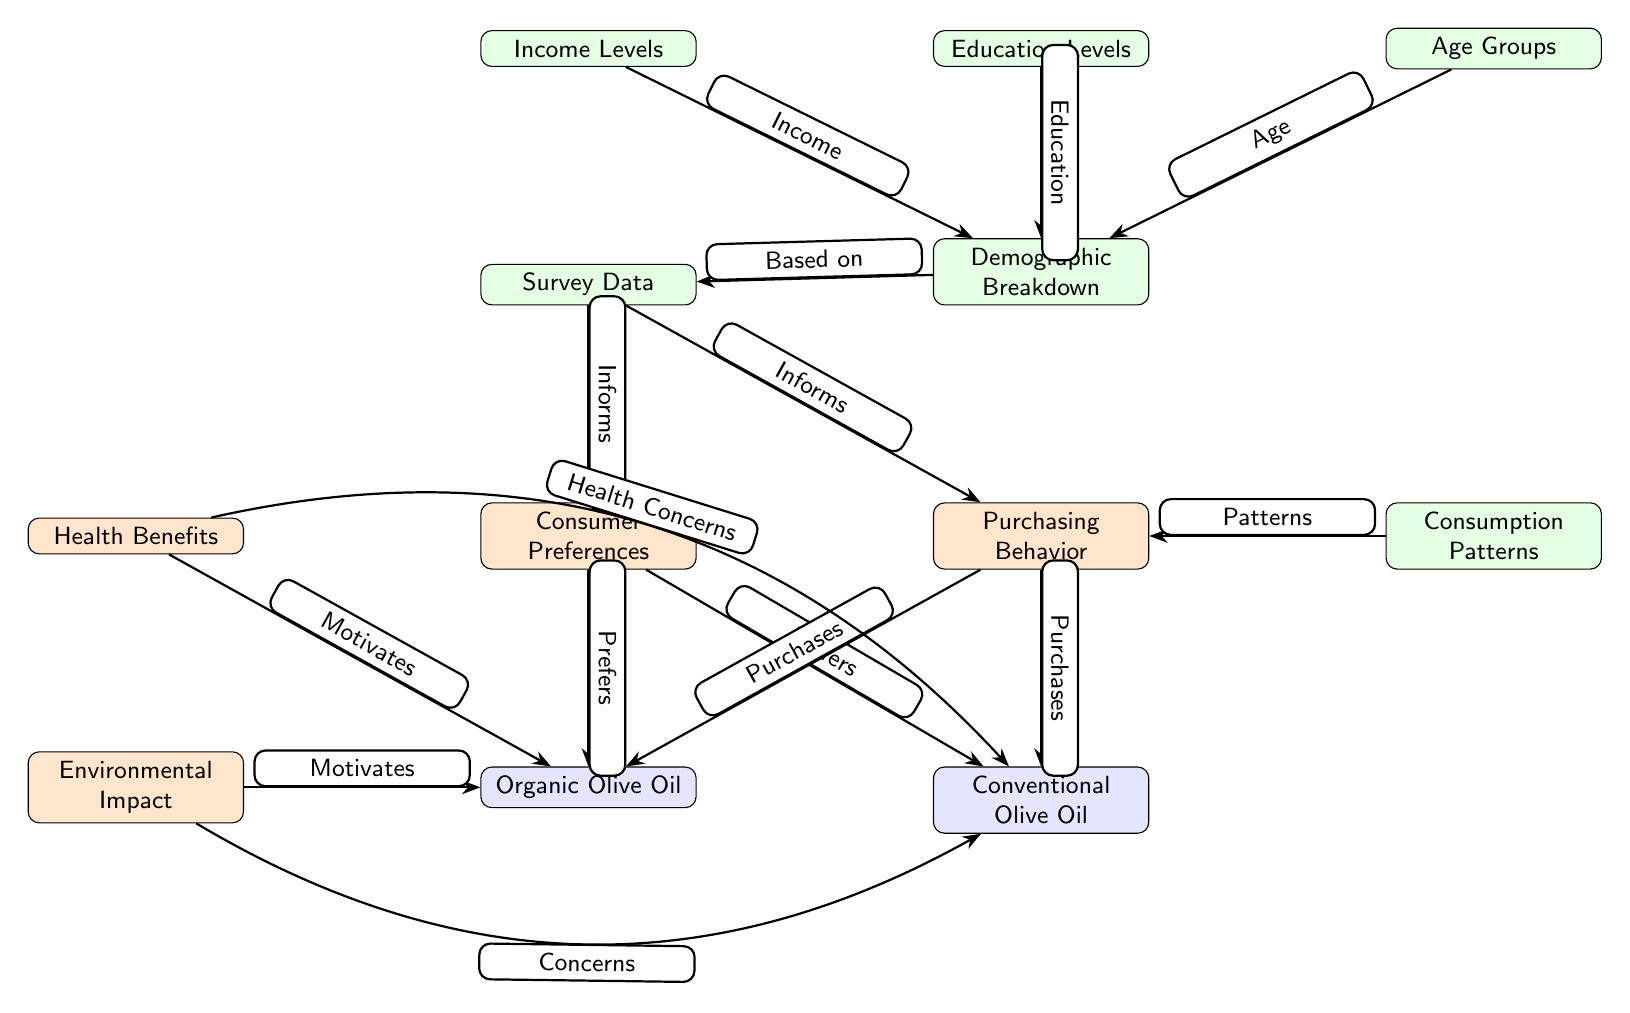What are the two main types of olive oil examined in the diagram? The diagram identifies two main types of olive oil: Organic Olive Oil and Conventional Olive Oil. These are the two nodes located beneath the main node labeled "Consumer Preferences" and "Purchasing Behavior."
Answer: Organic Olive Oil, Conventional Olive Oil How many nodes represent demographic factors in the diagram? There are three nodes representing demographic factors: Income Levels, Education Levels, and Age Groups. These nodes are connected to the Demographic Breakdown node, indicating that they contribute to understanding consumer preferences and purchasing behavior.
Answer: 3 What motivates the preference for organic olive oil according to the diagram? The diagram indicates that two main factors motivate the preference for Organic Olive Oil: Health Benefits and Environmental Impact. These two nodes point towards the Organic Olive Oil node, showing their influence on consumer choices.
Answer: Health Benefits, Environmental Impact Which node informs both consumer preferences and purchasing behavior? The Survey Data node serves as the source of information for both Consumer Preferences and Purchasing Behavior nodes, indicating that the survey results provide insights into both aspects. This is shown by the arrows leading from Survey Data to both nodes.
Answer: Survey Data What is the relationship between income levels and consumer preferences based on the diagram? Income levels are a contributing factor to the Demographic Breakdown, which in turn informs Consumer Preferences. This relationship illustrates that income influences consumer choices regarding olive oil types, specifically organic versus conventional.
Answer: Contributes to Demographic Breakdown How many arrows lead from the Health Benefits node? There are two arrows that lead from the Health Benefits node—one pointing towards Organic Olive Oil signifying motivation for preference, and another leading towards Conventional Olive Oil highlighting health concerns.
Answer: 2 What are the consumption patterns linked to according to the diagram? Consumption patterns are linked to the Purchasing Behavior node, indicating that these patterns reflect consumer choices regarding the types of olive oil purchased. The arrow from Consumption Patterns leads to Purchasing Behavior showing this relationship.
Answer: Purchasing Behavior Which demographic factor is NOT directly shown influencing purchasing behavior? The diagram does not show a direct influence from any demographic factor that is specifically not mentioned among the existing nodes, contributing towards Purchasing Behavior. All three demographic factors (Income, Education, and Age) are reflected in the Demographic Breakdown which informs consumer outcomes.
Answer: N/A What type of diagram structure is used to represent the principles of consumer preferences in this context? The diagram follows a flowchart structure, illustrating various nodes and their relationships, depicting how different elements like consumer preferences, purchasing behavior, and demographic factors are interconnected in understanding consumer behavior related to olive oil. This format visually outlines interdependencies and influences.
Answer: Flowchart structure 